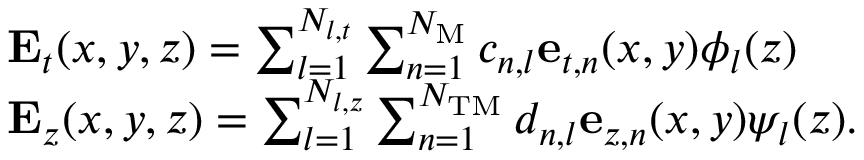<formula> <loc_0><loc_0><loc_500><loc_500>\begin{array} { r l } & { { E } _ { t } ( x , y , z ) = \sum _ { l = 1 } ^ { N _ { l , t } } \sum _ { n = 1 } ^ { N _ { M } } c _ { n , l } { e } _ { t , n } ( x , y ) \phi _ { l } ( z ) } \\ & { { E } _ { z } ( x , y , z ) = \sum _ { l = 1 } ^ { N _ { l , z } } \sum _ { n = 1 } ^ { N _ { T M } } d _ { n , l } { e } _ { z , n } ( x , y ) \psi _ { l } ( z ) . } \end{array}</formula> 